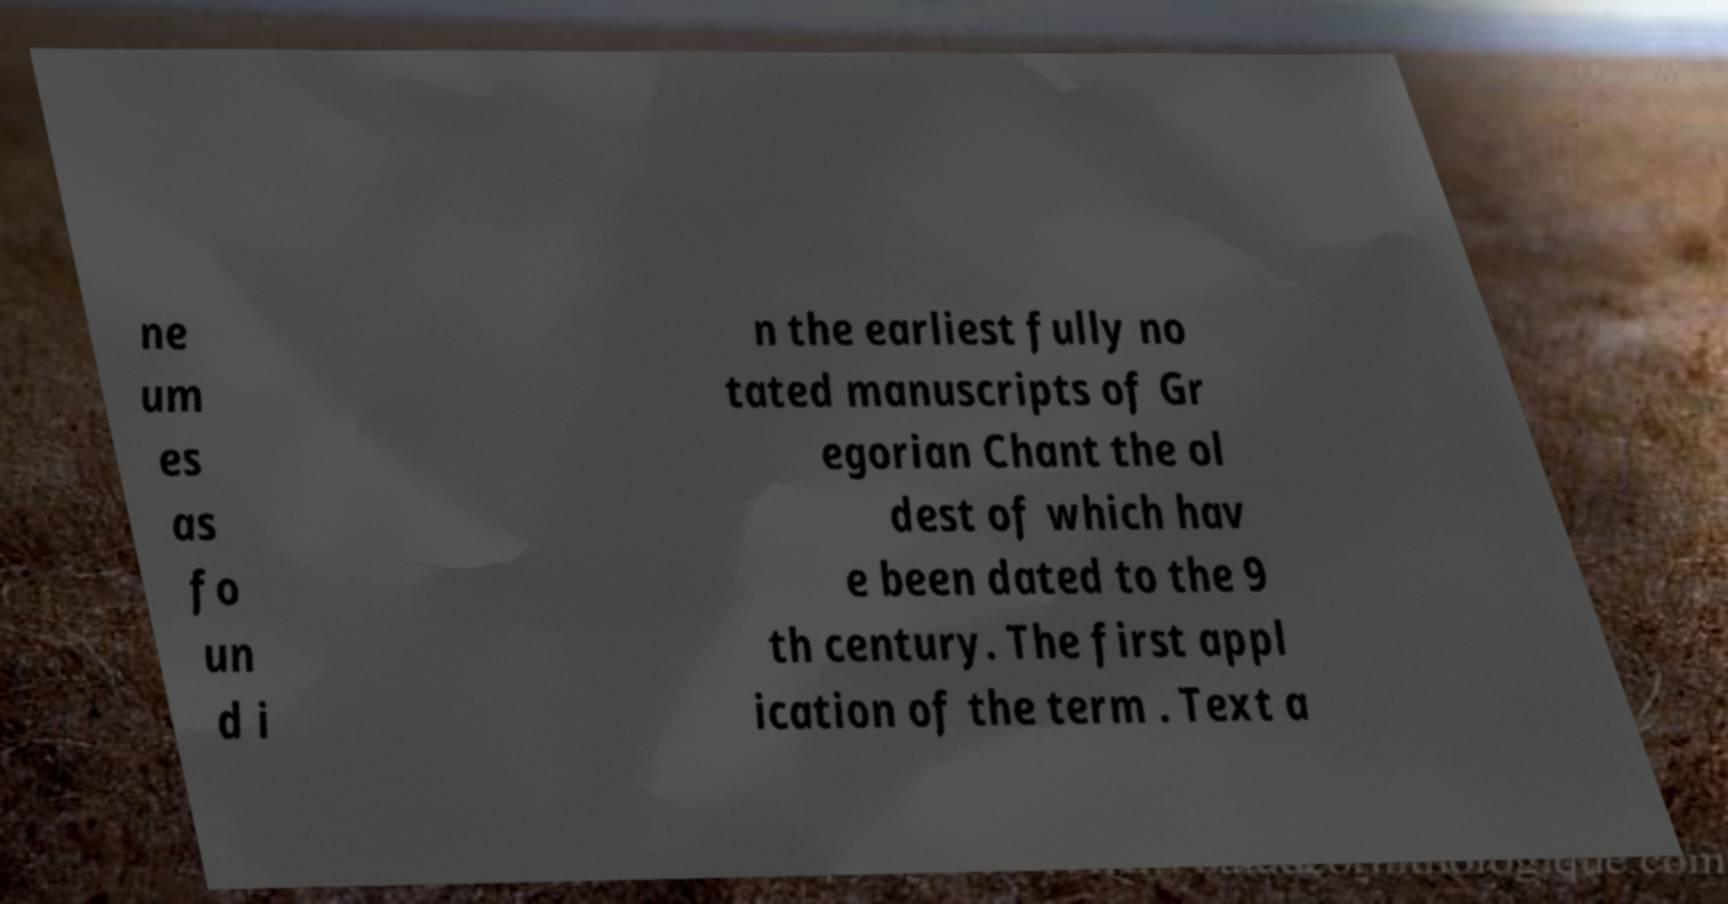Could you assist in decoding the text presented in this image and type it out clearly? ne um es as fo un d i n the earliest fully no tated manuscripts of Gr egorian Chant the ol dest of which hav e been dated to the 9 th century. The first appl ication of the term . Text a 